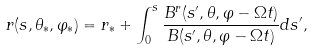<formula> <loc_0><loc_0><loc_500><loc_500>r ( s , \theta _ { \ast } , \varphi _ { \ast } ) = r _ { \ast } + \int _ { 0 } ^ { s } \frac { B ^ { r } ( s ^ { \prime } , \theta , \varphi - \Omega t ) } { B ( s ^ { \prime } , \theta , \varphi - \Omega t ) } d s ^ { \prime } ,</formula> 